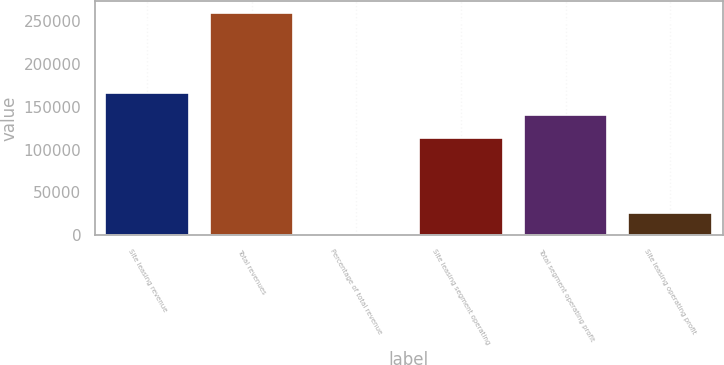Convert chart to OTSL. <chart><loc_0><loc_0><loc_500><loc_500><bar_chart><fcel>Site leasing revenue<fcel>Total revenues<fcel>Percentage of total revenue<fcel>Site leasing segment operating<fcel>Total segment operating profit<fcel>Site leasing operating profit<nl><fcel>166004<fcel>259991<fcel>62<fcel>114018<fcel>140011<fcel>26054.9<nl></chart> 